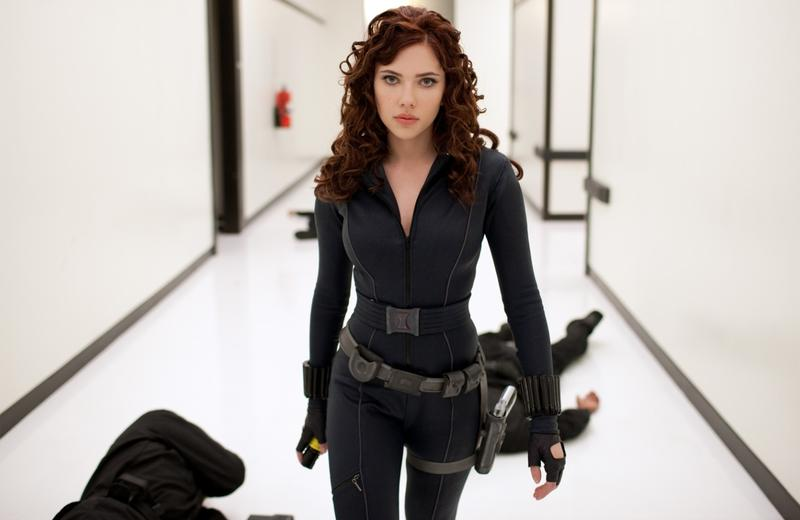What emotions might the character be experiencing in this scene? The character appears to be experiencing a mix of determination and focus, likely fueled by a sense of urgency. Her serious expression indicates she may be contemplating the next steps or reflecting on a recent battle. The fallen individuals in the background perhaps evoke a sense of resolve and a readiness to face further challenges. 